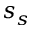<formula> <loc_0><loc_0><loc_500><loc_500>s _ { s }</formula> 